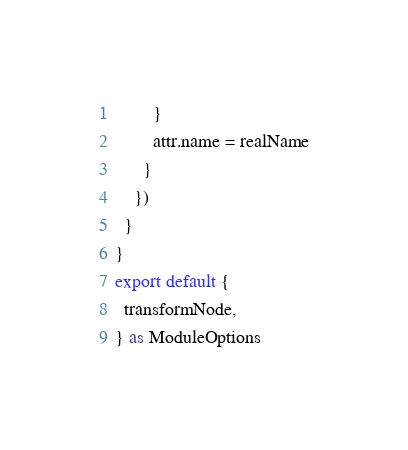Convert code to text. <code><loc_0><loc_0><loc_500><loc_500><_TypeScript_>        }
        attr.name = realName
      }
    })
  }
}
export default {
  transformNode,
} as ModuleOptions
</code> 